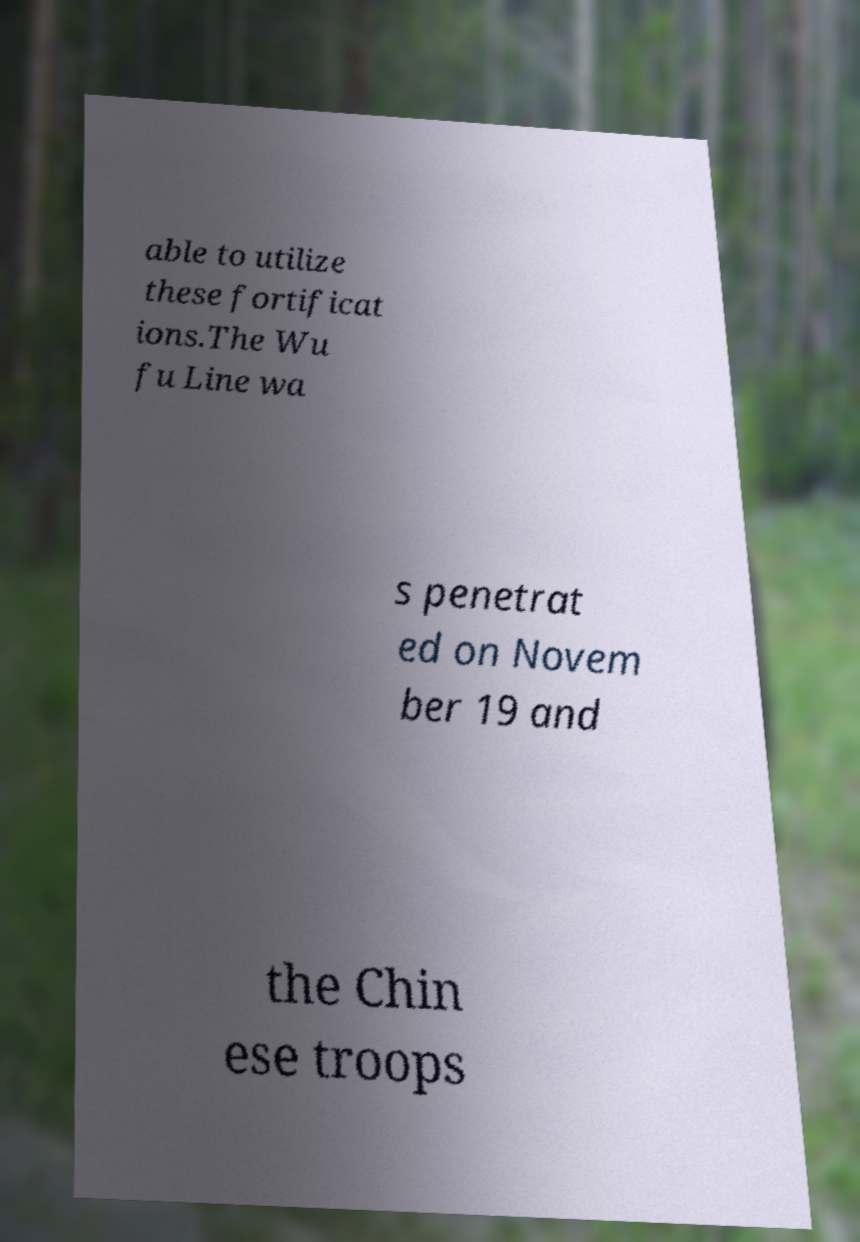Could you extract and type out the text from this image? able to utilize these fortificat ions.The Wu fu Line wa s penetrat ed on Novem ber 19 and the Chin ese troops 